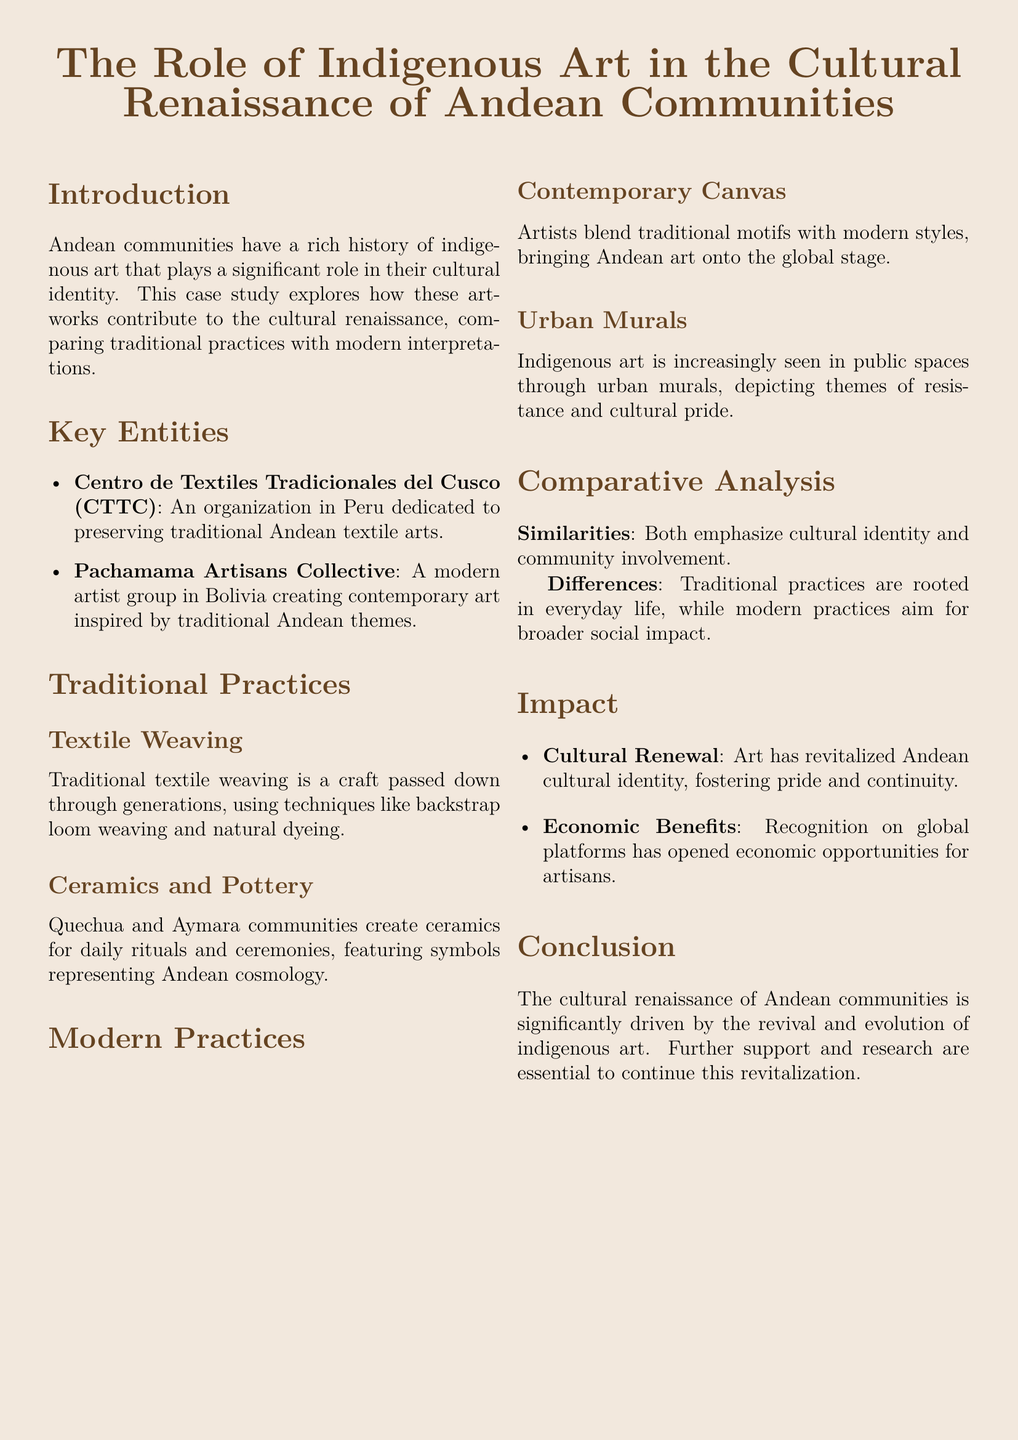What is the main focus of the case study? The case study explores the role of indigenous art in the cultural renaissance of Andean communities.
Answer: Indigenous art What organization in Peru is mentioned for textile preservation? The document lists the Centro de Textiles Tradicionales del Cusco as dedicated to preserving traditional Andean textile arts.
Answer: Centro de Textiles Tradicionales del Cusco What are two traditional art forms discussed? Traditional practices include textile weaving and ceramics.
Answer: Textile weaving and ceramics What do contemporary artists blend with modern styles? According to the document, artists blend traditional motifs with modern styles in their work.
Answer: Traditional motifs What type of art is increasingly seen in public spaces? The document mentions urban murals depicting themes of resistance and cultural pride.
Answer: Urban murals What is a similar aspect of traditional and modern practices? Both traditional and modern practices emphasize cultural identity and community involvement, according to the comparative analysis.
Answer: Cultural identity What impact has art had on Andean communities? The art revival has resulted in cultural renewal and economic benefits for artisans.
Answer: Cultural renewal and economic benefits What is a difference between traditional and modern practices? The document states that traditional practices are rooted in everyday life, while modern practices aim for broader social impact.
Answer: Everyday life vs. broader social impact What organization represents modern artists in Bolivia? The Pachamama Artisans Collective is mentioned as representing modern artists in Bolivia.
Answer: Pachamama Artisans Collective 